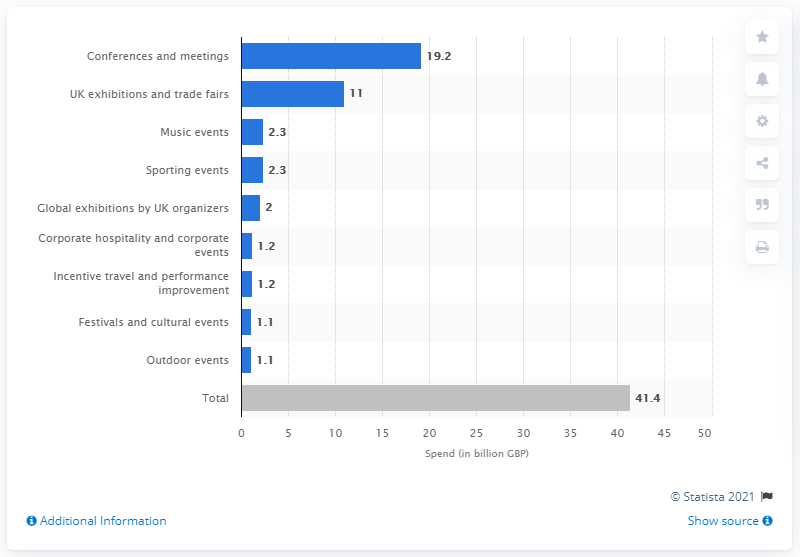What category had the second-highest expenditure in this chart? The category with the second-highest expenditure in the chart is 'UK exhibitions and trade fairs', with 11 billion GBP spent. 